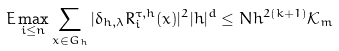<formula> <loc_0><loc_0><loc_500><loc_500>E \max _ { i \leq n } \sum _ { x \in G _ { h } } | \delta _ { h , \lambda } R ^ { \tau , h } _ { i } ( x ) | ^ { 2 } | h | ^ { d } \leq N h ^ { 2 ( k + 1 ) } \mathcal { K } _ { m }</formula> 